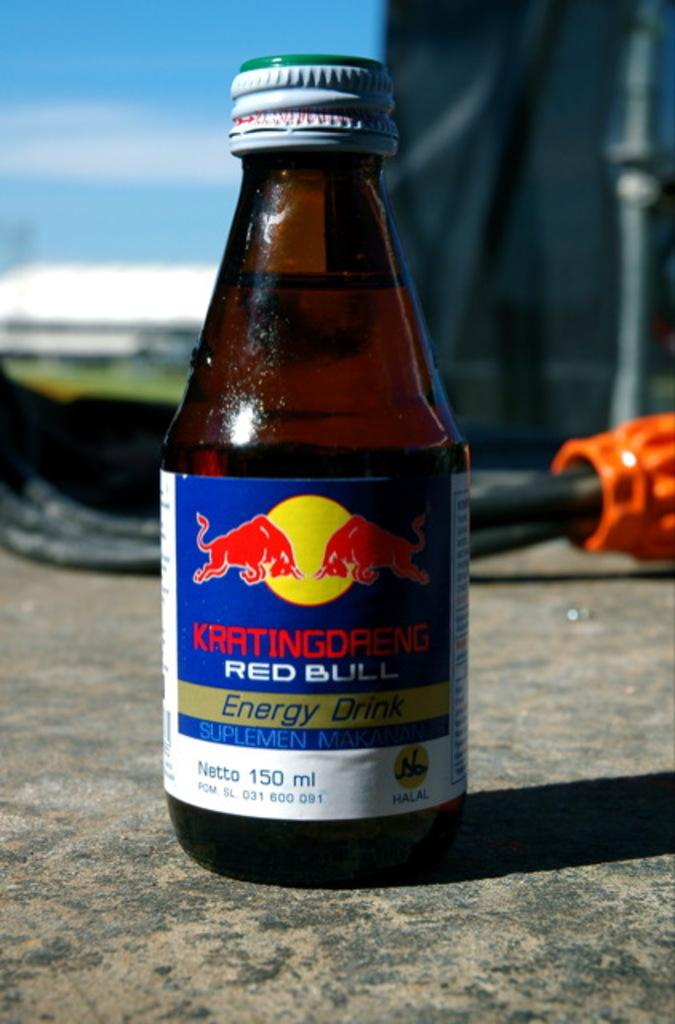<image>
Create a compact narrative representing the image presented. A glass bottle of a Red Bull energy drink 